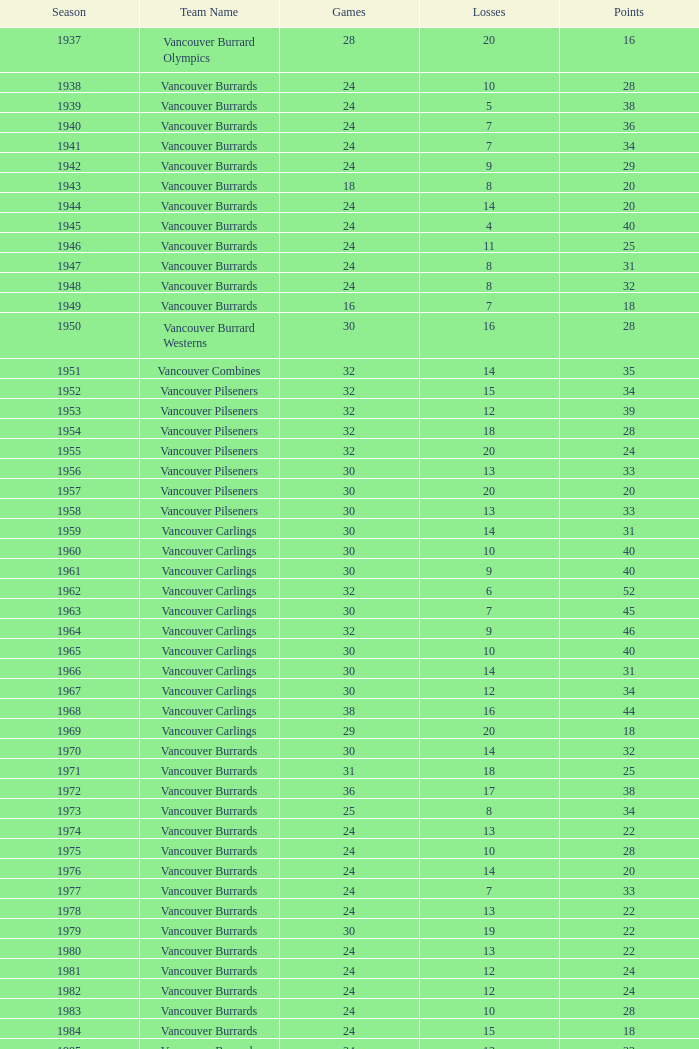What's the sum of points for the 1963 season when there are more than 30 games? None. 